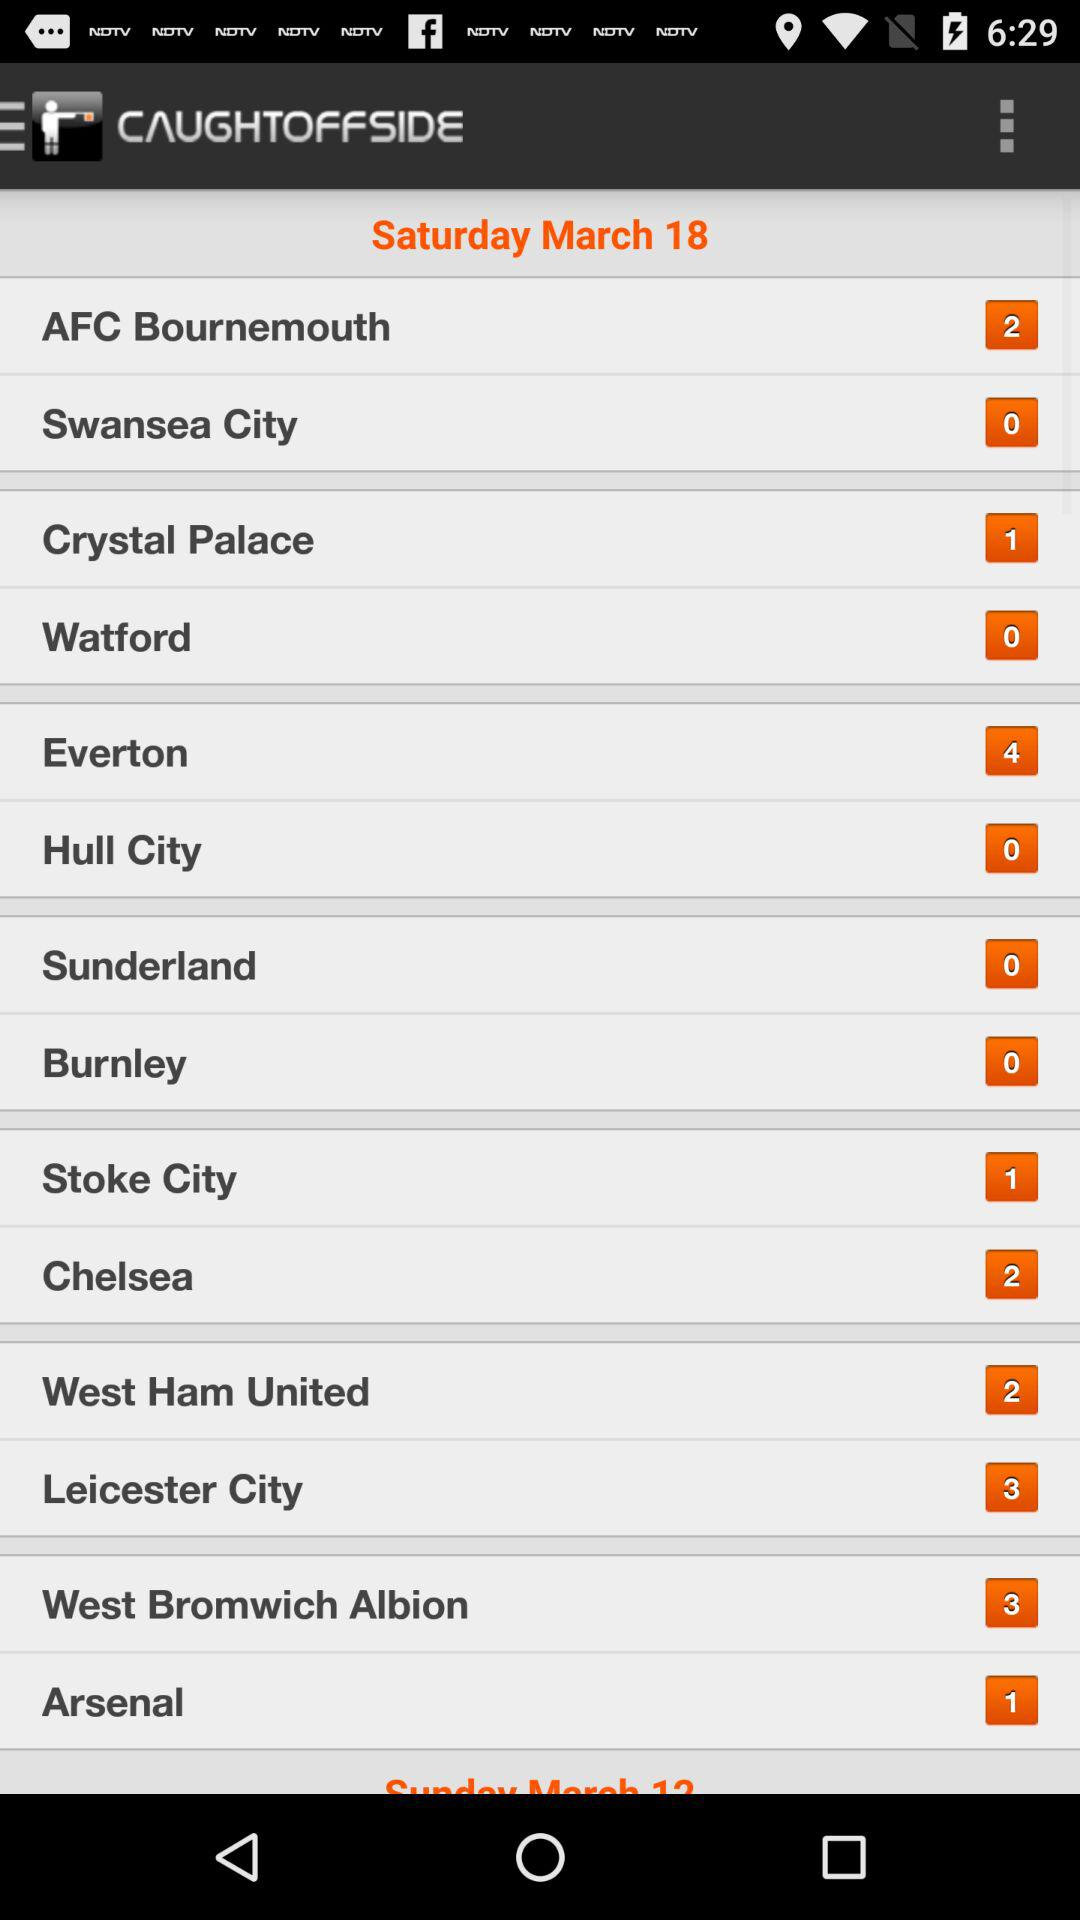What is the score for Burnley? The score for Burnley is 0. 